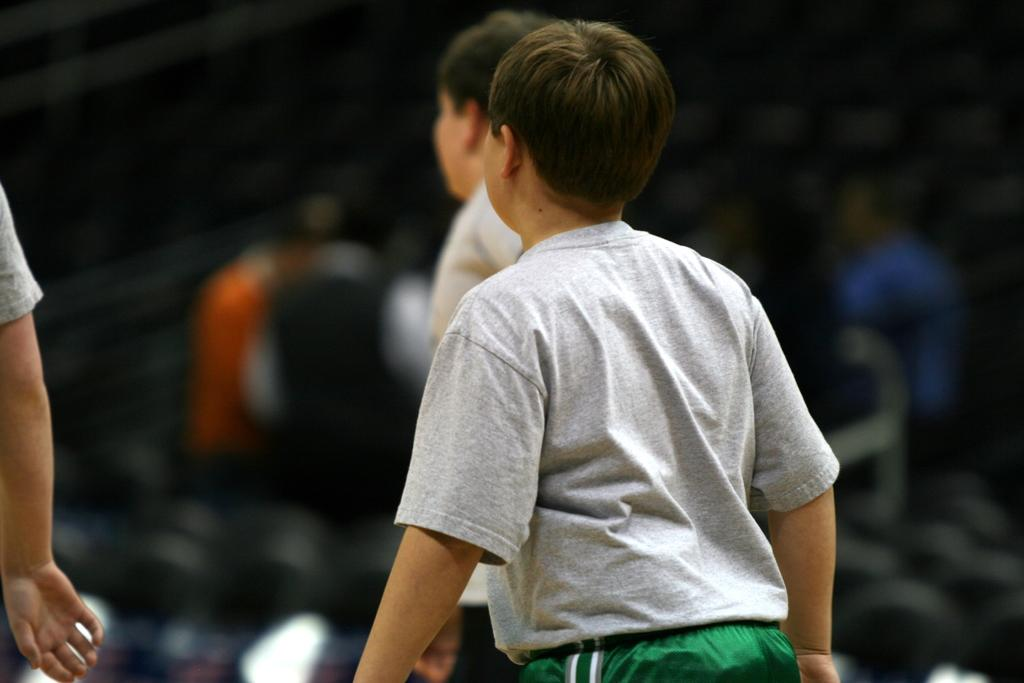How many boys are in the image? There are two boys in the image. What are the boys wearing? Both boys are wearing grey t-shirts and green shorts. Where are the boys standing? The boys are standing on the ground. Can you describe the background of the image? The background of the image is blurred. What type of fowl can be seen in the image? There is no fowl present in the image. What kind of food are the boys eating in the image? The image does not show the boys eating any food. 